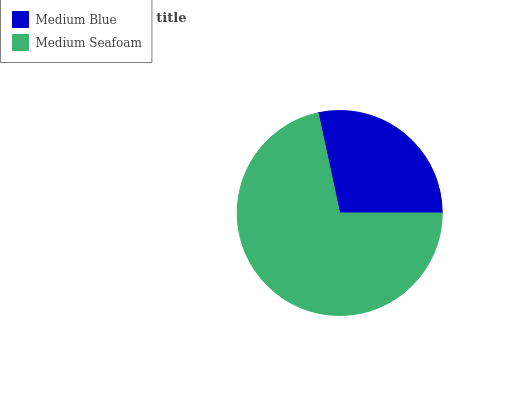Is Medium Blue the minimum?
Answer yes or no. Yes. Is Medium Seafoam the maximum?
Answer yes or no. Yes. Is Medium Seafoam the minimum?
Answer yes or no. No. Is Medium Seafoam greater than Medium Blue?
Answer yes or no. Yes. Is Medium Blue less than Medium Seafoam?
Answer yes or no. Yes. Is Medium Blue greater than Medium Seafoam?
Answer yes or no. No. Is Medium Seafoam less than Medium Blue?
Answer yes or no. No. Is Medium Seafoam the high median?
Answer yes or no. Yes. Is Medium Blue the low median?
Answer yes or no. Yes. Is Medium Blue the high median?
Answer yes or no. No. Is Medium Seafoam the low median?
Answer yes or no. No. 